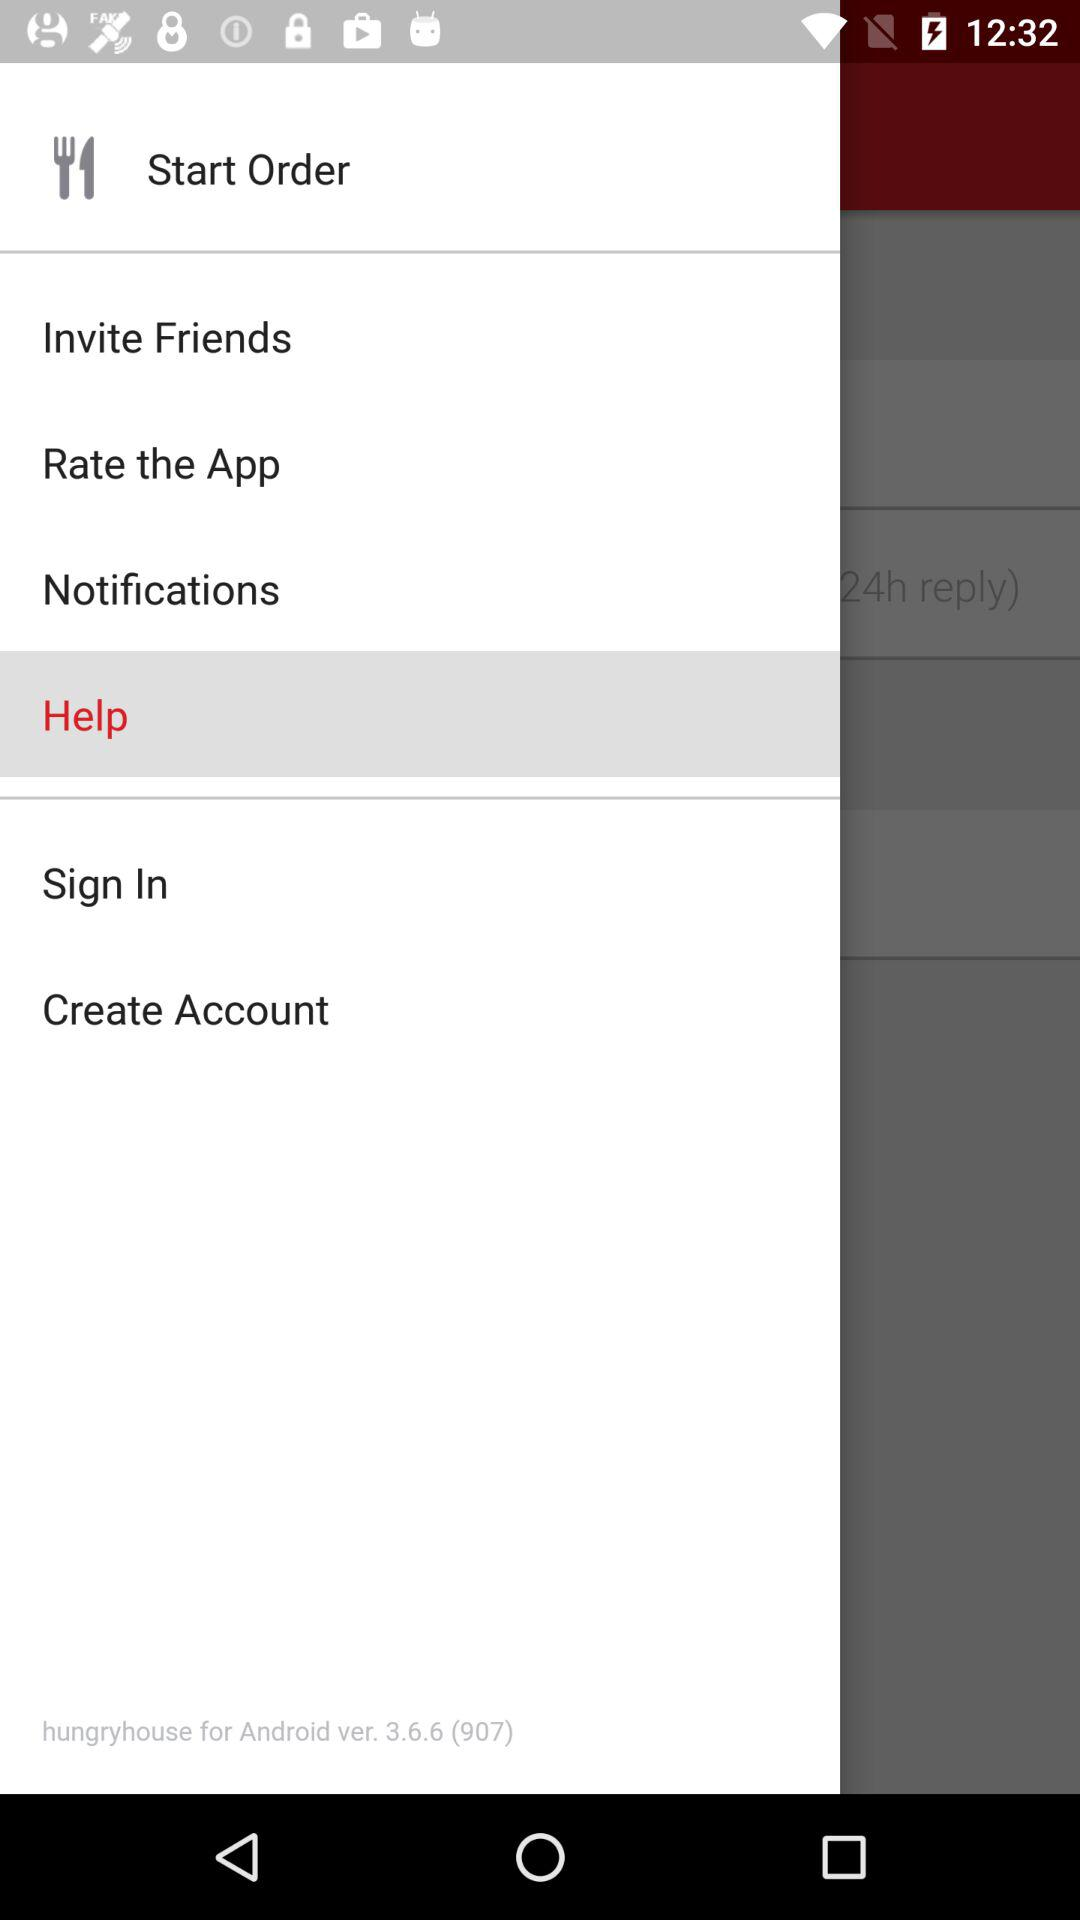What is the version? The version is 3.6.6 (907). 